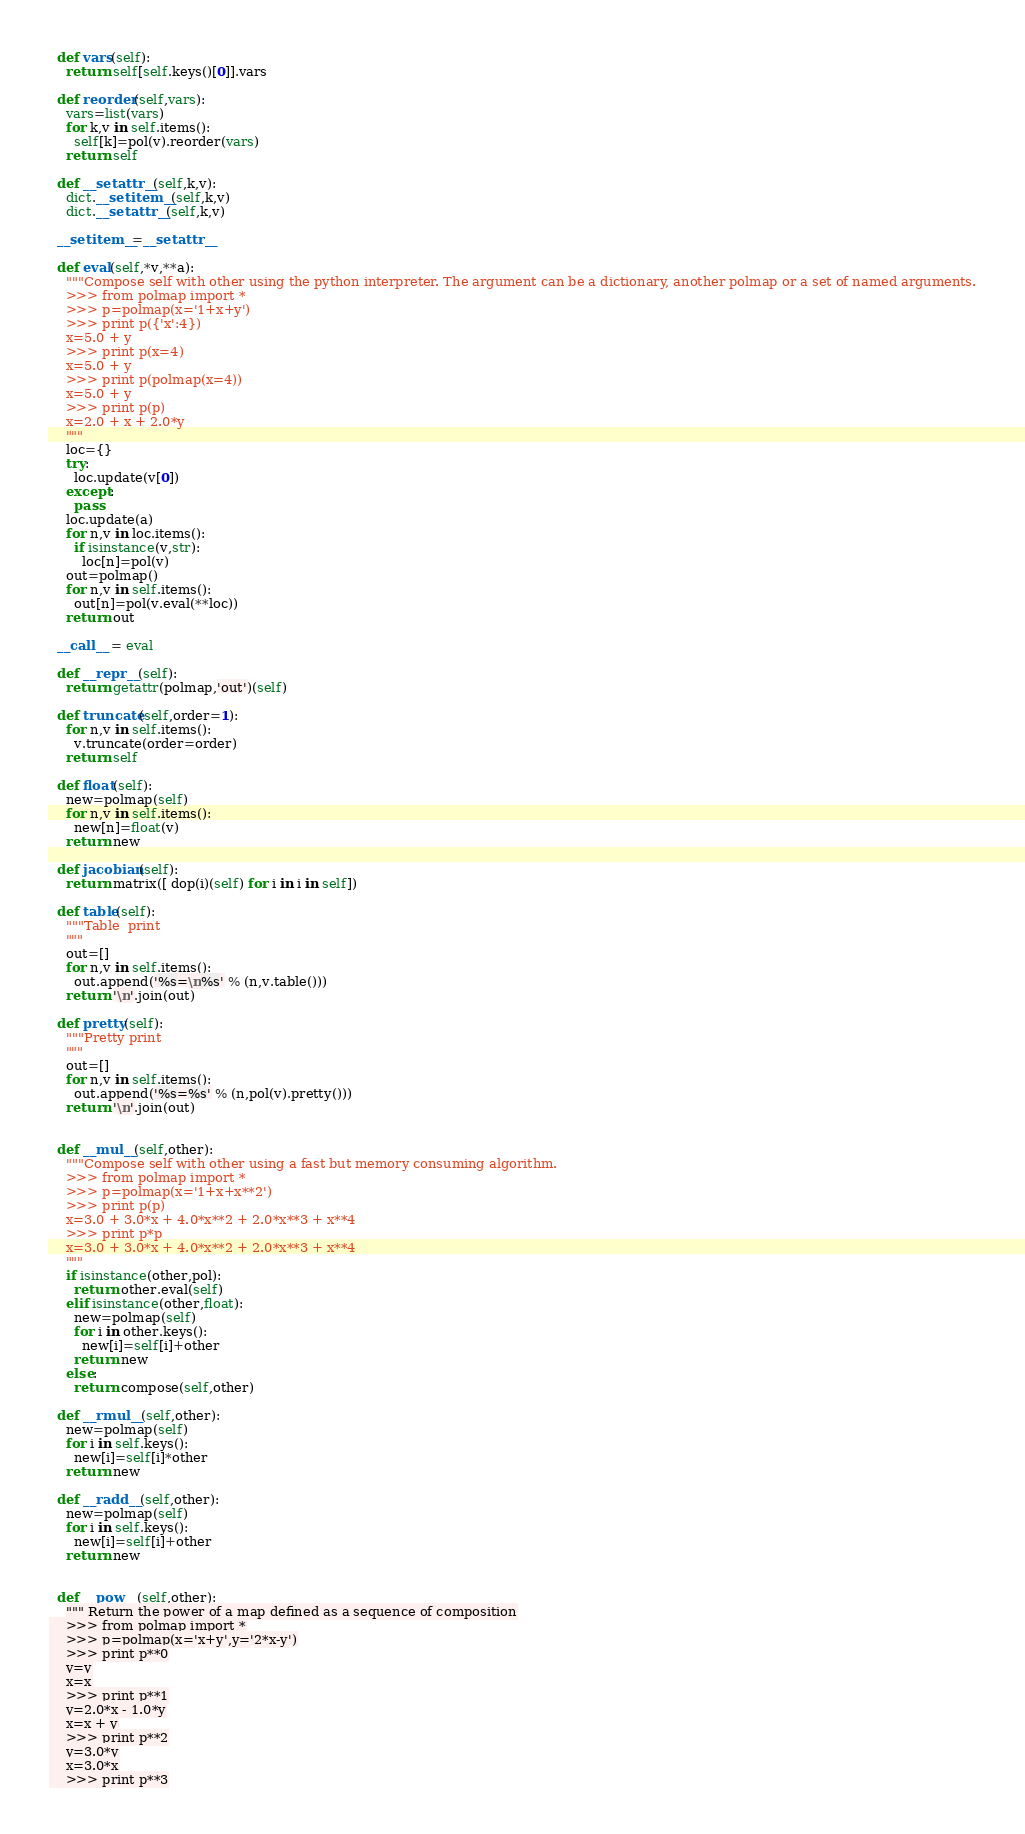Convert code to text. <code><loc_0><loc_0><loc_500><loc_500><_Python_>  def vars(self):
    return self[self.keys()[0]].vars

  def reorder(self,vars):
    vars=list(vars)
    for k,v in self.items():
      self[k]=pol(v).reorder(vars)
    return self

  def __setattr__(self,k,v):
    dict.__setitem__(self,k,v)
    dict.__setattr__(self,k,v)

  __setitem__=__setattr__

  def eval(self,*v,**a):
    """Compose self with other using the python interpreter. The argument can be a dictionary, another polmap or a set of named arguments.
    >>> from polmap import *
    >>> p=polmap(x='1+x+y')
    >>> print p({'x':4})
    x=5.0 + y
    >>> print p(x=4)
    x=5.0 + y
    >>> print p(polmap(x=4))
    x=5.0 + y
    >>> print p(p)
    x=2.0 + x + 2.0*y
    """
    loc={}
    try:
      loc.update(v[0])
    except:
      pass
    loc.update(a)
    for n,v in loc.items():
      if isinstance(v,str):
        loc[n]=pol(v)
    out=polmap()
    for n,v in self.items():
      out[n]=pol(v.eval(**loc))
    return out

  __call__ = eval

  def __repr__(self):
    return getattr(polmap,'out')(self)

  def truncate(self,order=1):
    for n,v in self.items():
      v.truncate(order=order)
    return self

  def float(self):
    new=polmap(self)
    for n,v in self.items():
      new[n]=float(v)
    return new

  def jacobian(self):
    return matrix([ dop(i)(self) for i in i in self])

  def table(self):
    """Table  print
    """
    out=[]
    for n,v in self.items():
      out.append('%s=\n%s' % (n,v.table()))
    return '\n'.join(out)

  def pretty(self):
    """Pretty print
    """
    out=[]
    for n,v in self.items():
      out.append('%s=%s' % (n,pol(v).pretty()))
    return '\n'.join(out)


  def __mul__(self,other):
    """Compose self with other using a fast but memory consuming algorithm.
    >>> from polmap import *
    >>> p=polmap(x='1+x+x**2')
    >>> print p(p)
    x=3.0 + 3.0*x + 4.0*x**2 + 2.0*x**3 + x**4
    >>> print p*p
    x=3.0 + 3.0*x + 4.0*x**2 + 2.0*x**3 + x**4
    """
    if isinstance(other,pol):
      return other.eval(self)
    elif isinstance(other,float):
      new=polmap(self)
      for i in other.keys():
        new[i]=self[i]+other
      return new
    else:
      return compose(self,other)

  def __rmul__(self,other):
    new=polmap(self)
    for i in self.keys():
      new[i]=self[i]*other
    return new

  def __radd__(self,other):
    new=polmap(self)
    for i in self.keys():
      new[i]=self[i]+other
    return new


  def __pow__(self,other):
    """ Return the power of a map defined as a sequence of composition
    >>> from polmap import *
    >>> p=polmap(x='x+y',y='2*x-y')
    >>> print p**0
    y=y
    x=x
    >>> print p**1
    y=2.0*x - 1.0*y
    x=x + y
    >>> print p**2
    y=3.0*y
    x=3.0*x
    >>> print p**3</code> 